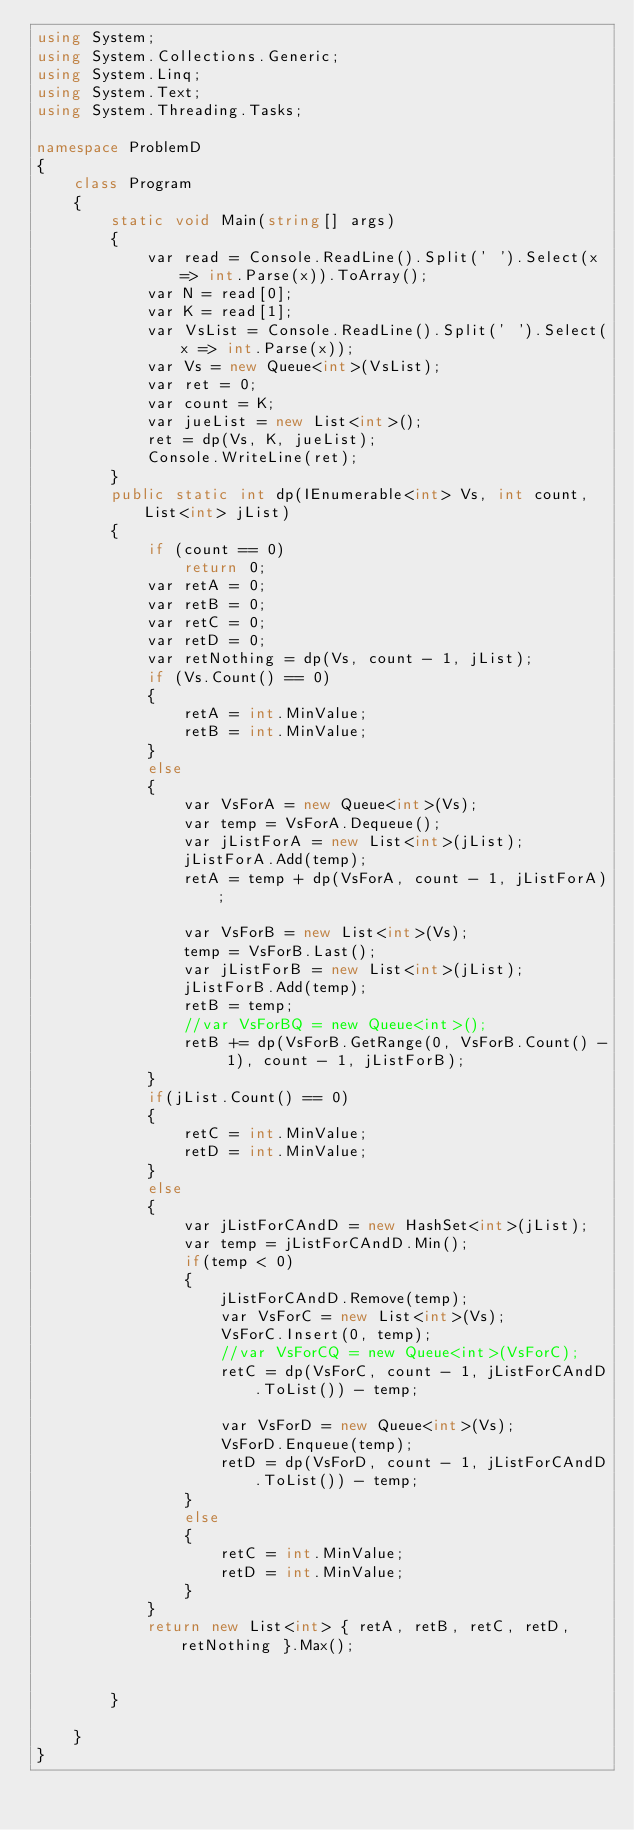Convert code to text. <code><loc_0><loc_0><loc_500><loc_500><_C#_>using System;
using System.Collections.Generic;
using System.Linq;
using System.Text;
using System.Threading.Tasks;

namespace ProblemD
{
    class Program
    {
        static void Main(string[] args)
        {
            var read = Console.ReadLine().Split(' ').Select(x => int.Parse(x)).ToArray();
            var N = read[0];
            var K = read[1];
            var VsList = Console.ReadLine().Split(' ').Select(x => int.Parse(x));
            var Vs = new Queue<int>(VsList);
            var ret = 0;
            var count = K;
            var jueList = new List<int>();
            ret = dp(Vs, K, jueList);
            Console.WriteLine(ret);
        }
        public static int dp(IEnumerable<int> Vs, int count, List<int> jList)
        {
            if (count == 0)
                return 0;
            var retA = 0;
            var retB = 0;
            var retC = 0;
            var retD = 0;
            var retNothing = dp(Vs, count - 1, jList);
            if (Vs.Count() == 0)
            {
                retA = int.MinValue;
                retB = int.MinValue;
            }
            else
            {
                var VsForA = new Queue<int>(Vs);
                var temp = VsForA.Dequeue();
                var jListForA = new List<int>(jList);
                jListForA.Add(temp);
                retA = temp + dp(VsForA, count - 1, jListForA);

                var VsForB = new List<int>(Vs);
                temp = VsForB.Last();
                var jListForB = new List<int>(jList);
                jListForB.Add(temp);
                retB = temp;
                //var VsForBQ = new Queue<int>();
                retB += dp(VsForB.GetRange(0, VsForB.Count() - 1), count - 1, jListForB);
            }
            if(jList.Count() == 0)
            {
                retC = int.MinValue;
                retD = int.MinValue;
            }
            else
            {
                var jListForCAndD = new HashSet<int>(jList);
                var temp = jListForCAndD.Min();
                if(temp < 0)
                {
                    jListForCAndD.Remove(temp);
                    var VsForC = new List<int>(Vs);
                    VsForC.Insert(0, temp);
                    //var VsForCQ = new Queue<int>(VsForC);
                    retC = dp(VsForC, count - 1, jListForCAndD.ToList()) - temp;

                    var VsForD = new Queue<int>(Vs);
                    VsForD.Enqueue(temp);
                    retD = dp(VsForD, count - 1, jListForCAndD.ToList()) - temp;
                }
                else
                {
                    retC = int.MinValue;
                    retD = int.MinValue;
                }
            }
            return new List<int> { retA, retB, retC, retD, retNothing }.Max();


        }

    }
}
</code> 